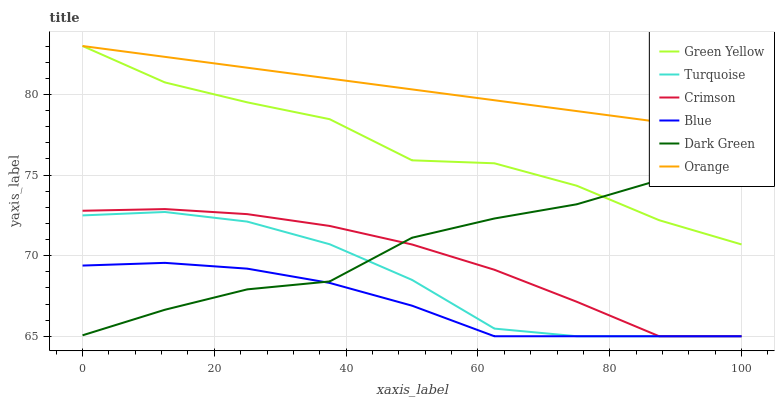Does Blue have the minimum area under the curve?
Answer yes or no. Yes. Does Orange have the maximum area under the curve?
Answer yes or no. Yes. Does Turquoise have the minimum area under the curve?
Answer yes or no. No. Does Turquoise have the maximum area under the curve?
Answer yes or no. No. Is Orange the smoothest?
Answer yes or no. Yes. Is Green Yellow the roughest?
Answer yes or no. Yes. Is Turquoise the smoothest?
Answer yes or no. No. Is Turquoise the roughest?
Answer yes or no. No. Does Blue have the lowest value?
Answer yes or no. Yes. Does Orange have the lowest value?
Answer yes or no. No. Does Green Yellow have the highest value?
Answer yes or no. Yes. Does Turquoise have the highest value?
Answer yes or no. No. Is Dark Green less than Orange?
Answer yes or no. Yes. Is Orange greater than Blue?
Answer yes or no. Yes. Does Dark Green intersect Blue?
Answer yes or no. Yes. Is Dark Green less than Blue?
Answer yes or no. No. Is Dark Green greater than Blue?
Answer yes or no. No. Does Dark Green intersect Orange?
Answer yes or no. No. 